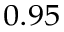Convert formula to latex. <formula><loc_0><loc_0><loc_500><loc_500>_ { 0 . 9 5 }</formula> 